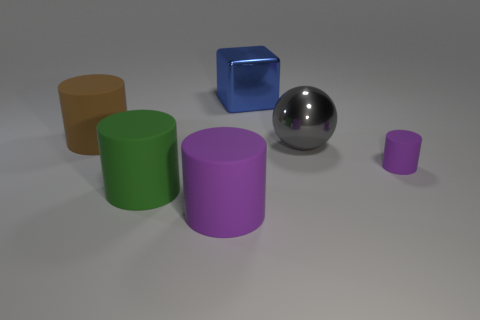Is the color of the small rubber thing the same as the large metallic block?
Keep it short and to the point. No. The green matte thing that is the same shape as the large purple matte object is what size?
Provide a succinct answer. Large. Is there any other thing that is made of the same material as the big cube?
Your answer should be compact. Yes. The large blue metallic object has what shape?
Ensure brevity in your answer.  Cube. What is the shape of the blue metal object that is the same size as the green cylinder?
Offer a very short reply. Cube. Is there anything else that has the same color as the big metal block?
Offer a terse response. No. There is a cube that is made of the same material as the big gray sphere; what is its size?
Make the answer very short. Large. There is a big green thing; does it have the same shape as the big shiny object that is behind the big brown cylinder?
Make the answer very short. No. The blue shiny thing has what size?
Keep it short and to the point. Large. Are there fewer big gray things behind the large purple matte cylinder than small shiny blocks?
Provide a short and direct response. No. 